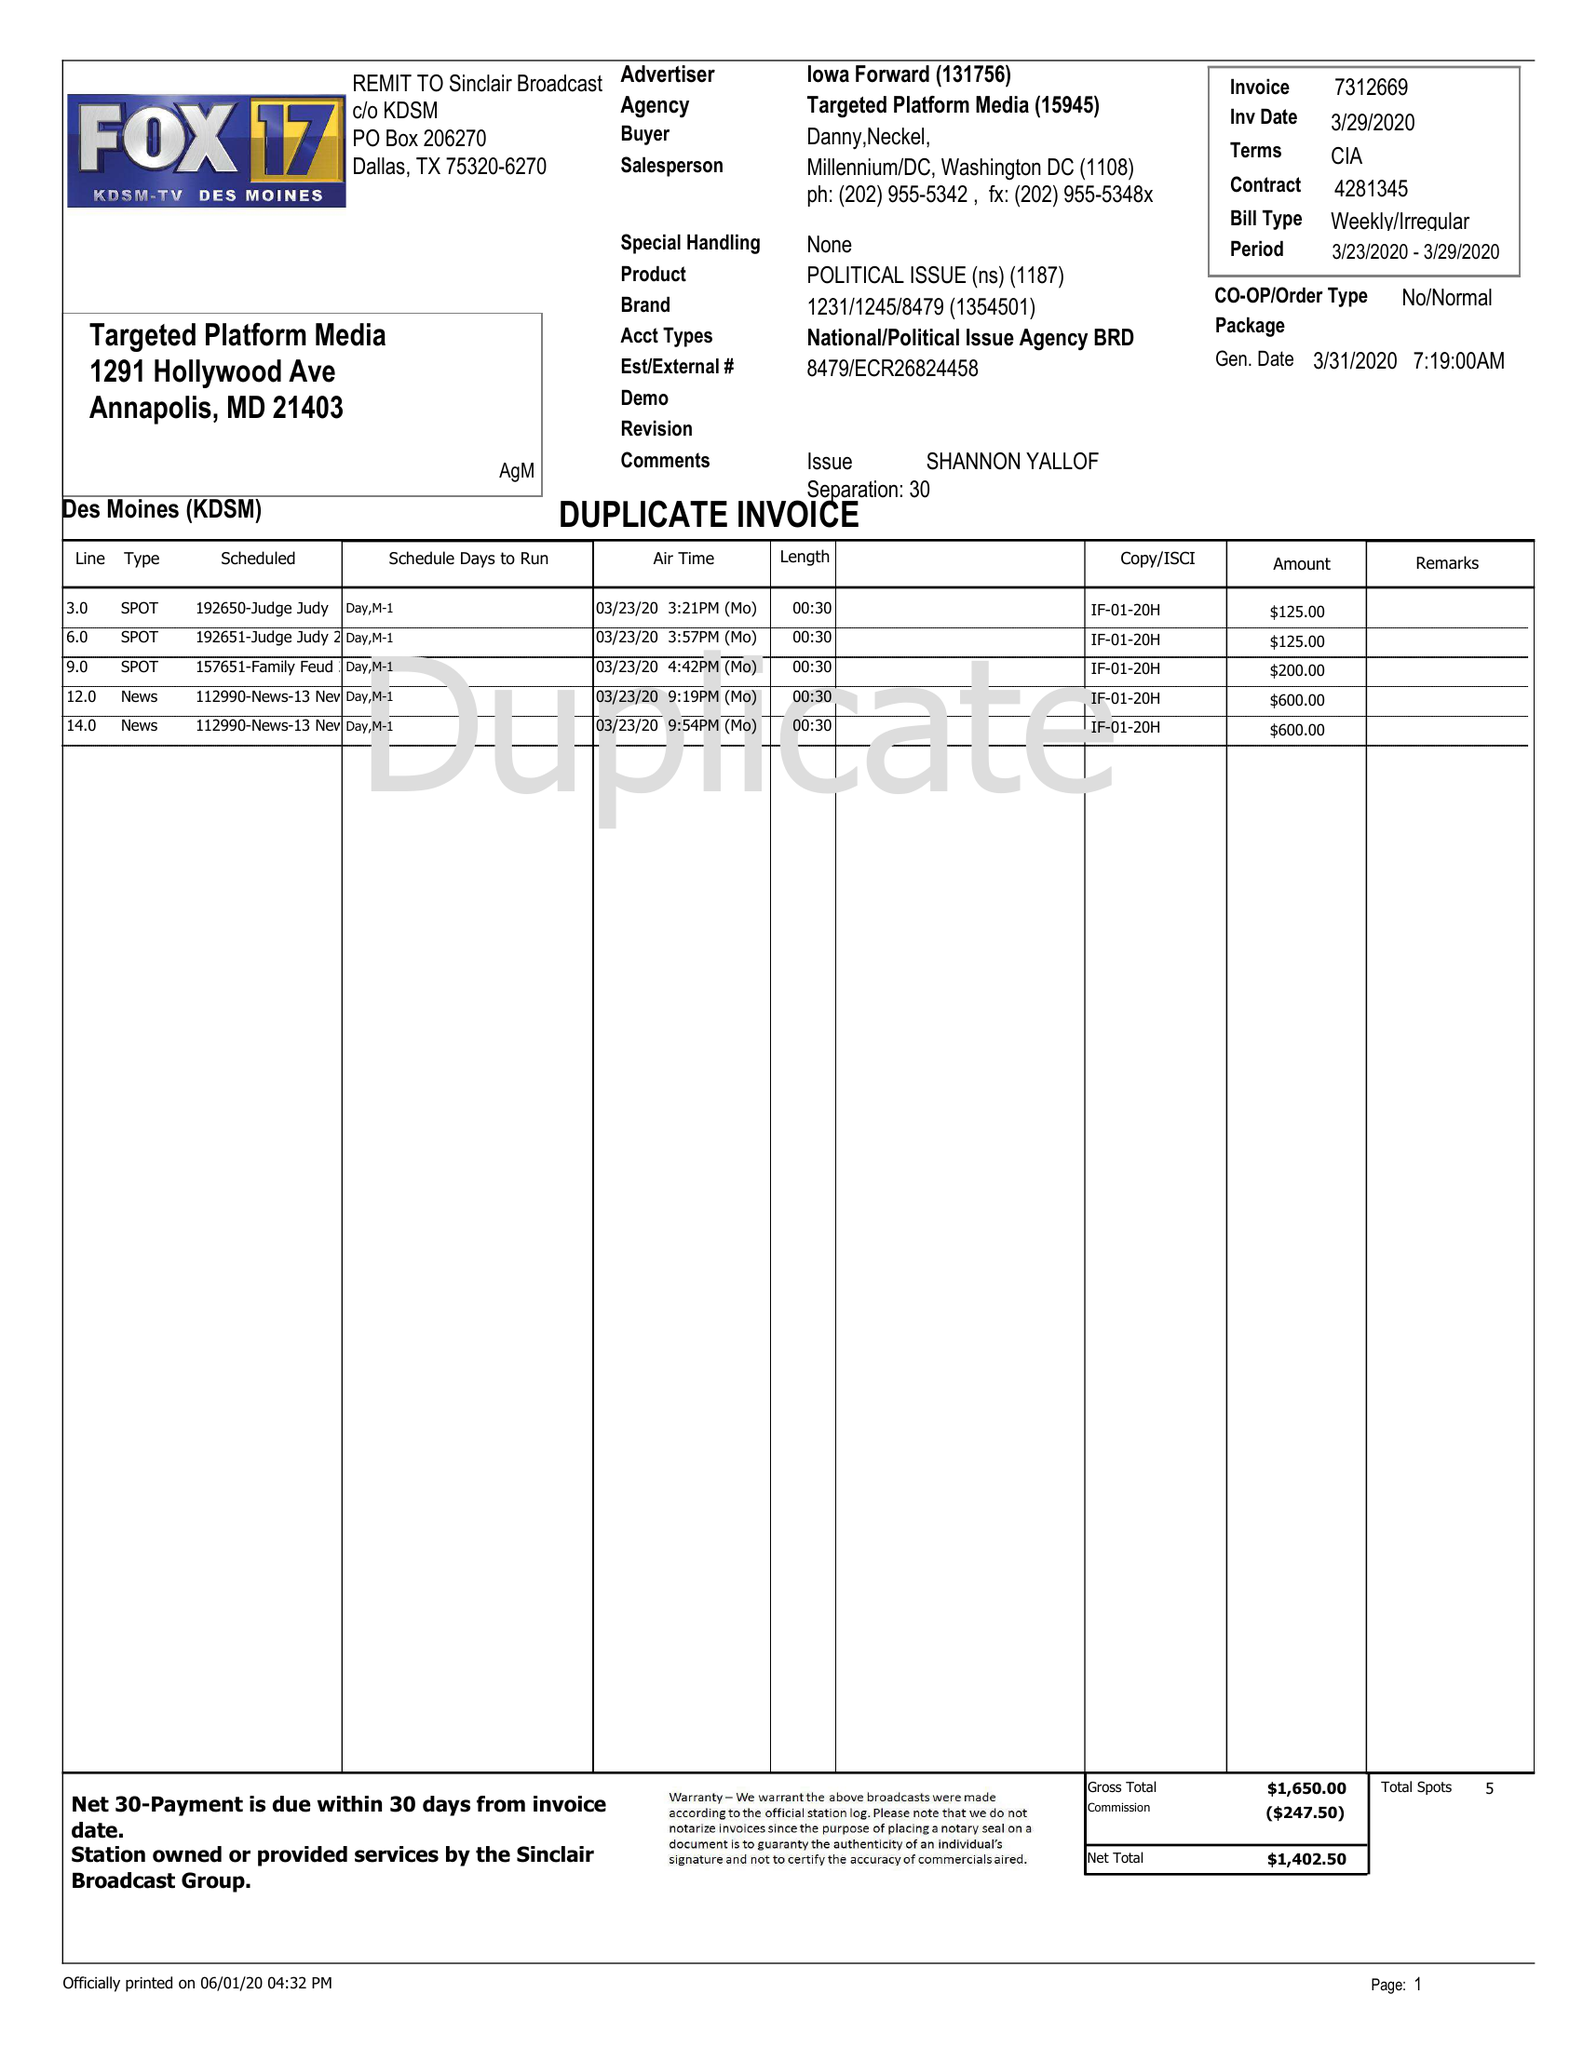What is the value for the flight_to?
Answer the question using a single word or phrase. 03/29/20 